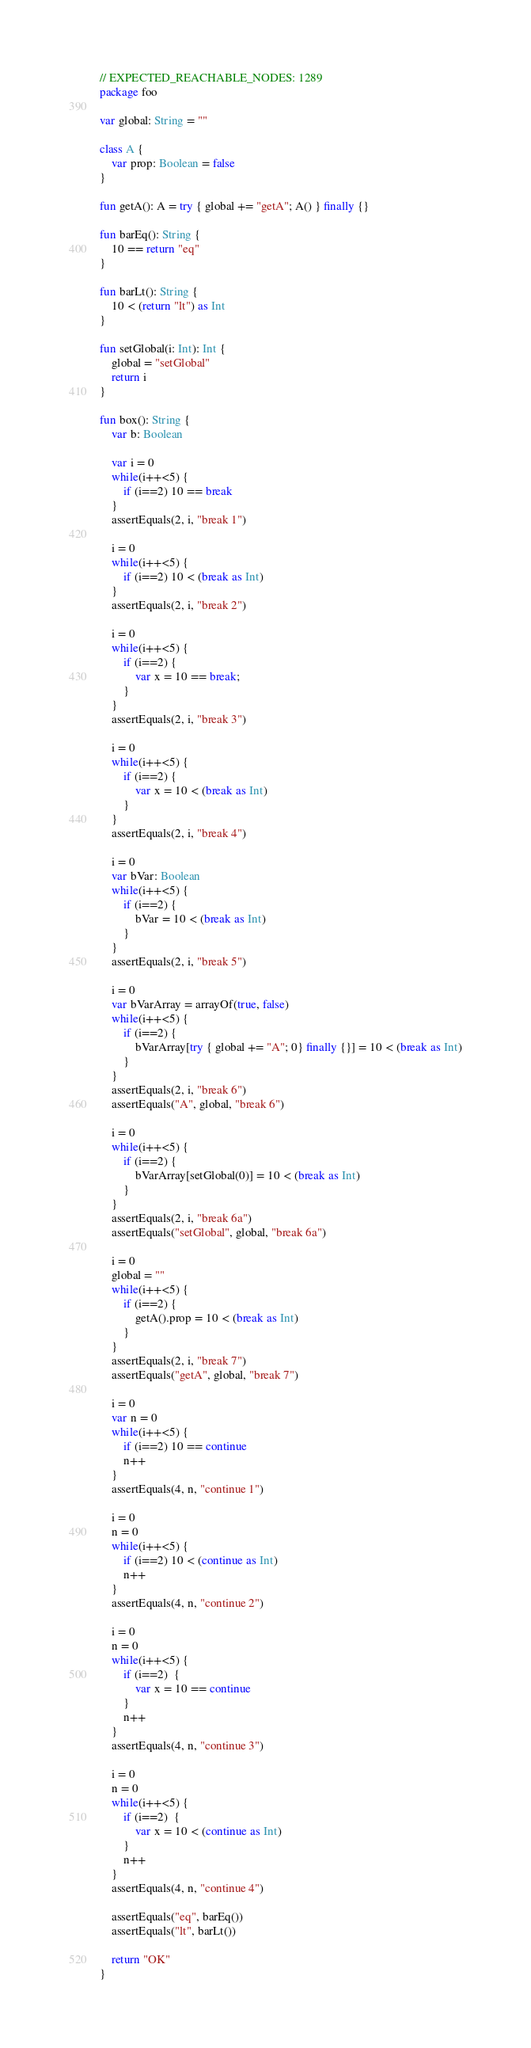Convert code to text. <code><loc_0><loc_0><loc_500><loc_500><_Kotlin_>// EXPECTED_REACHABLE_NODES: 1289
package foo

var global: String = ""

class A {
    var prop: Boolean = false
}

fun getA(): A = try { global += "getA"; A() } finally {}

fun barEq(): String {
    10 == return "eq"
}

fun barLt(): String {
    10 < (return "lt") as Int
}

fun setGlobal(i: Int): Int {
    global = "setGlobal"
    return i
}

fun box(): String {
    var b: Boolean

    var i = 0
    while(i++<5) {
        if (i==2) 10 == break
    }
    assertEquals(2, i, "break 1")

    i = 0
    while(i++<5) {
        if (i==2) 10 < (break as Int)
    }
    assertEquals(2, i, "break 2")

    i = 0
    while(i++<5) {
        if (i==2) {
            var x = 10 == break;
        }
    }
    assertEquals(2, i, "break 3")

    i = 0
    while(i++<5) {
        if (i==2) {
            var x = 10 < (break as Int)
        }
    }
    assertEquals(2, i, "break 4")

    i = 0
    var bVar: Boolean
    while(i++<5) {
        if (i==2) {
            bVar = 10 < (break as Int)
        }
    }
    assertEquals(2, i, "break 5")

    i = 0
    var bVarArray = arrayOf(true, false)
    while(i++<5) {
        if (i==2) {
            bVarArray[try { global += "A"; 0} finally {}] = 10 < (break as Int)
        }
    }
    assertEquals(2, i, "break 6")
    assertEquals("A", global, "break 6")

    i = 0
    while(i++<5) {
        if (i==2) {
            bVarArray[setGlobal(0)] = 10 < (break as Int)
        }
    }
    assertEquals(2, i, "break 6a")
    assertEquals("setGlobal", global, "break 6a")

    i = 0
    global = ""
    while(i++<5) {
        if (i==2) {
            getA().prop = 10 < (break as Int)
        }
    }
    assertEquals(2, i, "break 7")
    assertEquals("getA", global, "break 7")

    i = 0
    var n = 0
    while(i++<5) {
        if (i==2) 10 == continue
        n++
    }
    assertEquals(4, n, "continue 1")

    i = 0
    n = 0
    while(i++<5) {
        if (i==2) 10 < (continue as Int)
        n++
    }
    assertEquals(4, n, "continue 2")

    i = 0
    n = 0
    while(i++<5) {
        if (i==2)  {
            var x = 10 == continue
        }
        n++
    }
    assertEquals(4, n, "continue 3")

    i = 0
    n = 0
    while(i++<5) {
        if (i==2)  {
            var x = 10 < (continue as Int)
        }
        n++
    }
    assertEquals(4, n, "continue 4")

    assertEquals("eq", barEq())
    assertEquals("lt", barLt())

    return "OK"
}</code> 